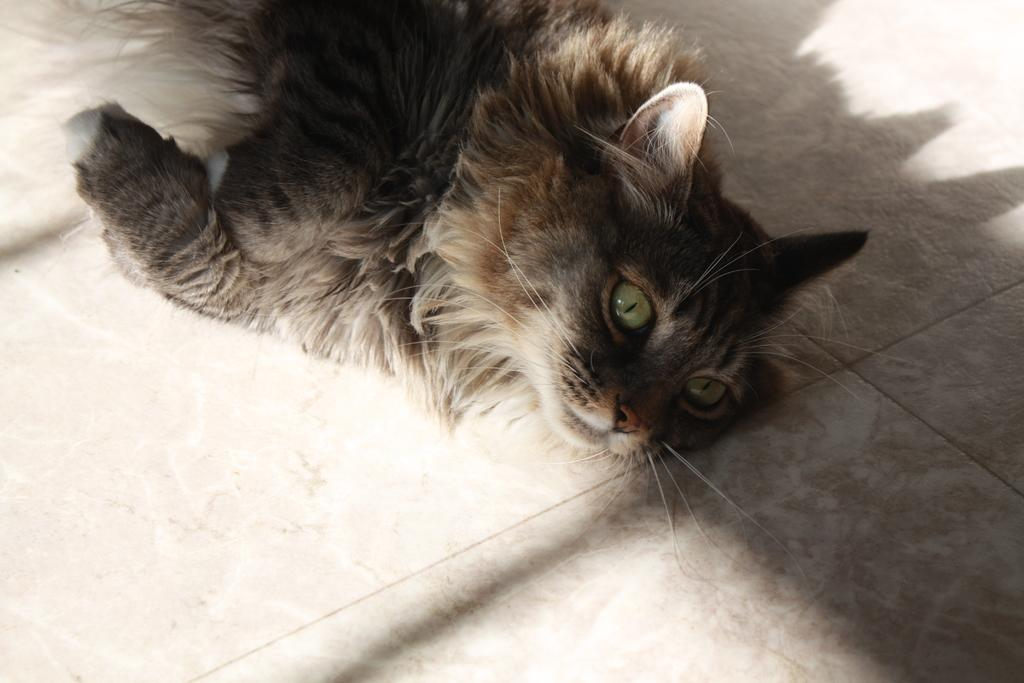What type of animal is in the picture? There is a cat in the picture. What is the cat doing in the picture? The cat is laying on the floor. What is the floor made of in the picture? The floor has tiles. What color is the cat in the picture? The cat is gray in color. What type of punishment is the cat receiving in the picture? There is no indication of punishment in the picture; the cat is simply laying on the floor. Can you see a lake in the background of the picture? There is no lake present in the image; it only features a cat laying on a tiled floor. 